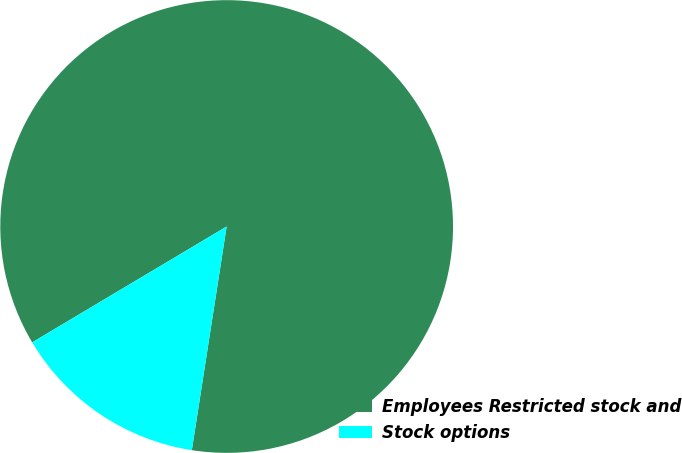<chart> <loc_0><loc_0><loc_500><loc_500><pie_chart><fcel>Employees Restricted stock and<fcel>Stock options<nl><fcel>86.01%<fcel>13.99%<nl></chart> 